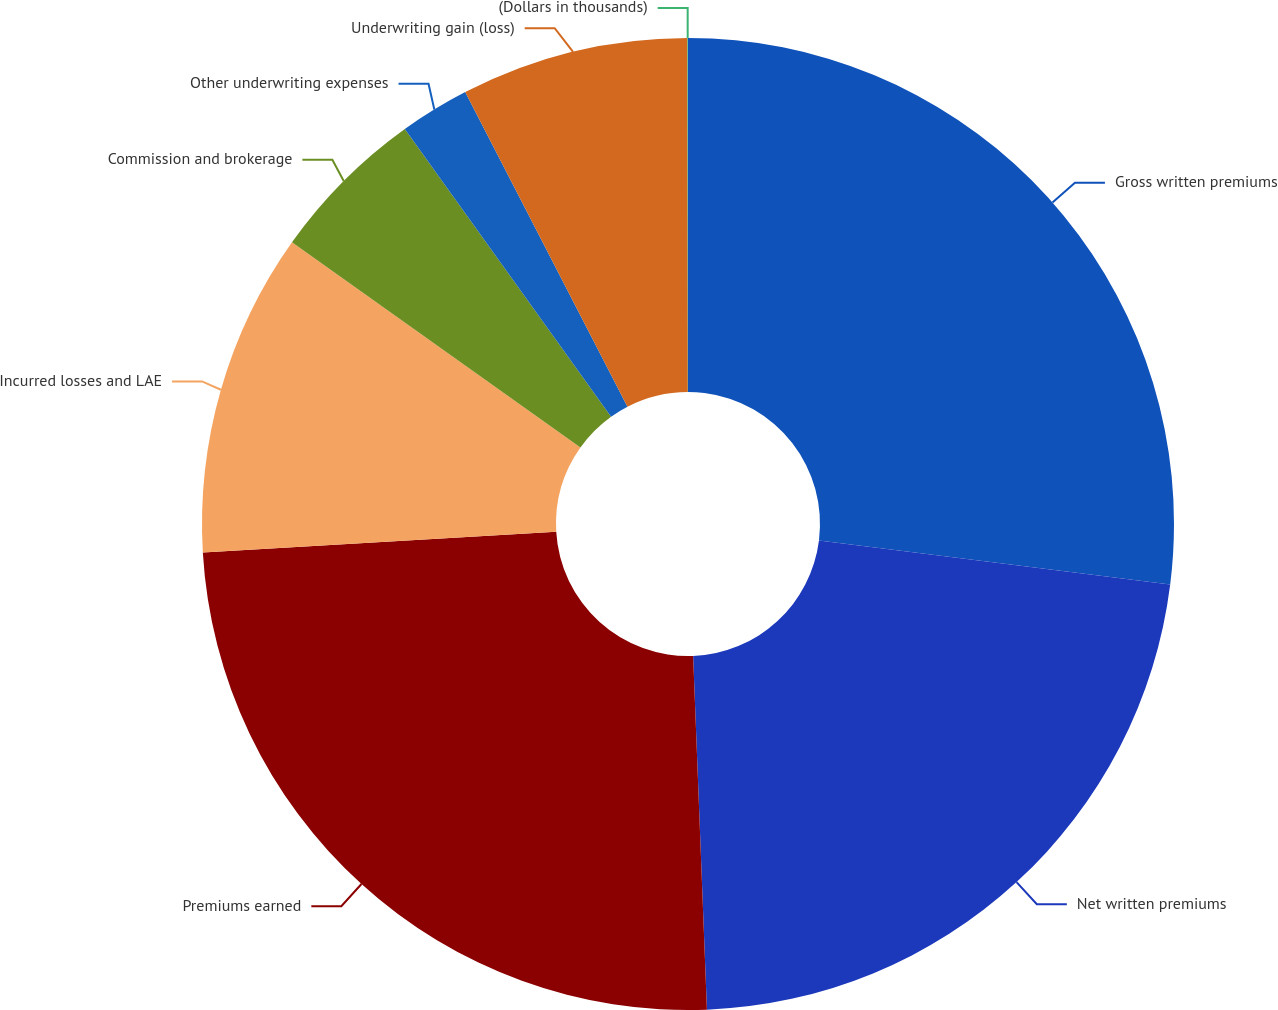<chart> <loc_0><loc_0><loc_500><loc_500><pie_chart><fcel>Gross written premiums<fcel>Net written premiums<fcel>Premiums earned<fcel>Incurred losses and LAE<fcel>Commission and brokerage<fcel>Other underwriting expenses<fcel>Underwriting gain (loss)<fcel>(Dollars in thousands)<nl><fcel>26.99%<fcel>22.39%<fcel>24.69%<fcel>10.77%<fcel>5.26%<fcel>2.32%<fcel>7.56%<fcel>0.02%<nl></chart> 